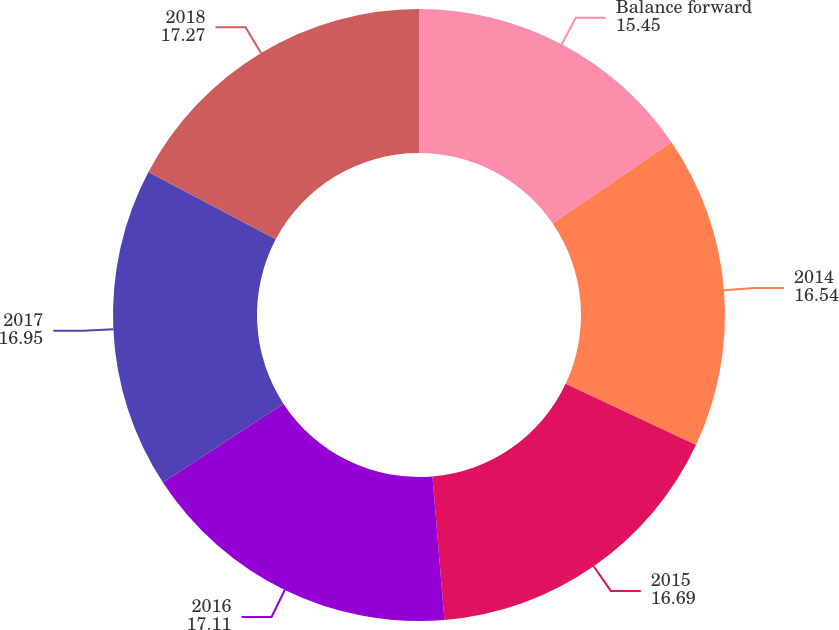<chart> <loc_0><loc_0><loc_500><loc_500><pie_chart><fcel>Balance forward<fcel>2014<fcel>2015<fcel>2016<fcel>2017<fcel>2018<nl><fcel>15.45%<fcel>16.54%<fcel>16.69%<fcel>17.11%<fcel>16.95%<fcel>17.27%<nl></chart> 